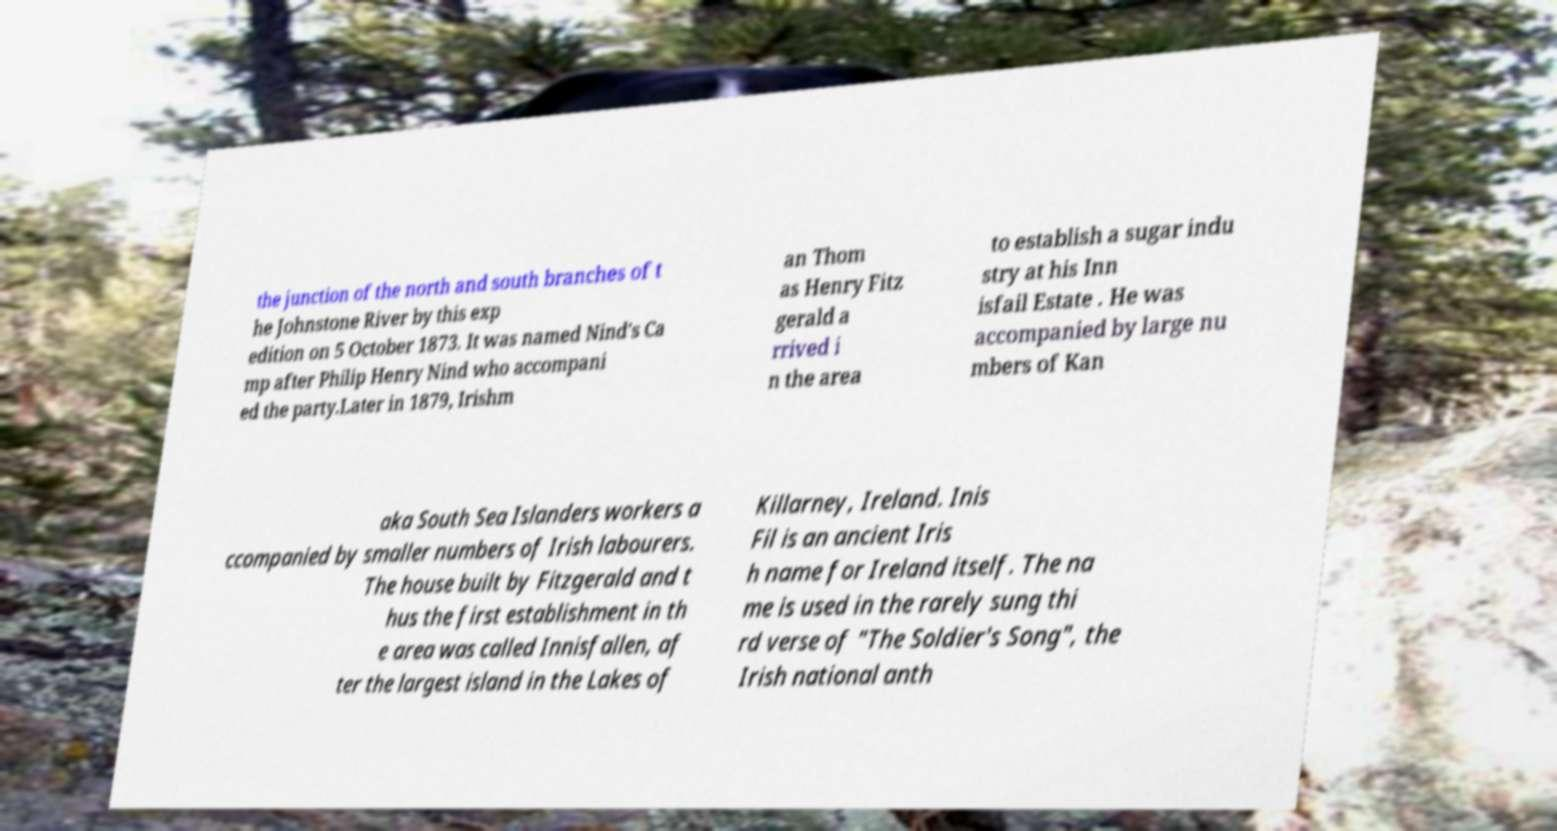There's text embedded in this image that I need extracted. Can you transcribe it verbatim? the junction of the north and south branches of t he Johnstone River by this exp edition on 5 October 1873. It was named Nind's Ca mp after Philip Henry Nind who accompani ed the party.Later in 1879, Irishm an Thom as Henry Fitz gerald a rrived i n the area to establish a sugar indu stry at his Inn isfail Estate . He was accompanied by large nu mbers of Kan aka South Sea Islanders workers a ccompanied by smaller numbers of Irish labourers. The house built by Fitzgerald and t hus the first establishment in th e area was called Innisfallen, af ter the largest island in the Lakes of Killarney, Ireland. Inis Fil is an ancient Iris h name for Ireland itself. The na me is used in the rarely sung thi rd verse of "The Soldier's Song", the Irish national anth 